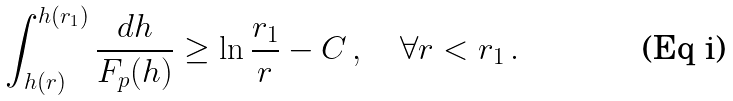Convert formula to latex. <formula><loc_0><loc_0><loc_500><loc_500>\int _ { h ( r ) } ^ { h ( r _ { 1 } ) } \frac { d h } { F _ { p } ( h ) } \geq \ln \frac { r _ { 1 } } { r } - C \, , \quad \forall r < r _ { 1 } \, .</formula> 